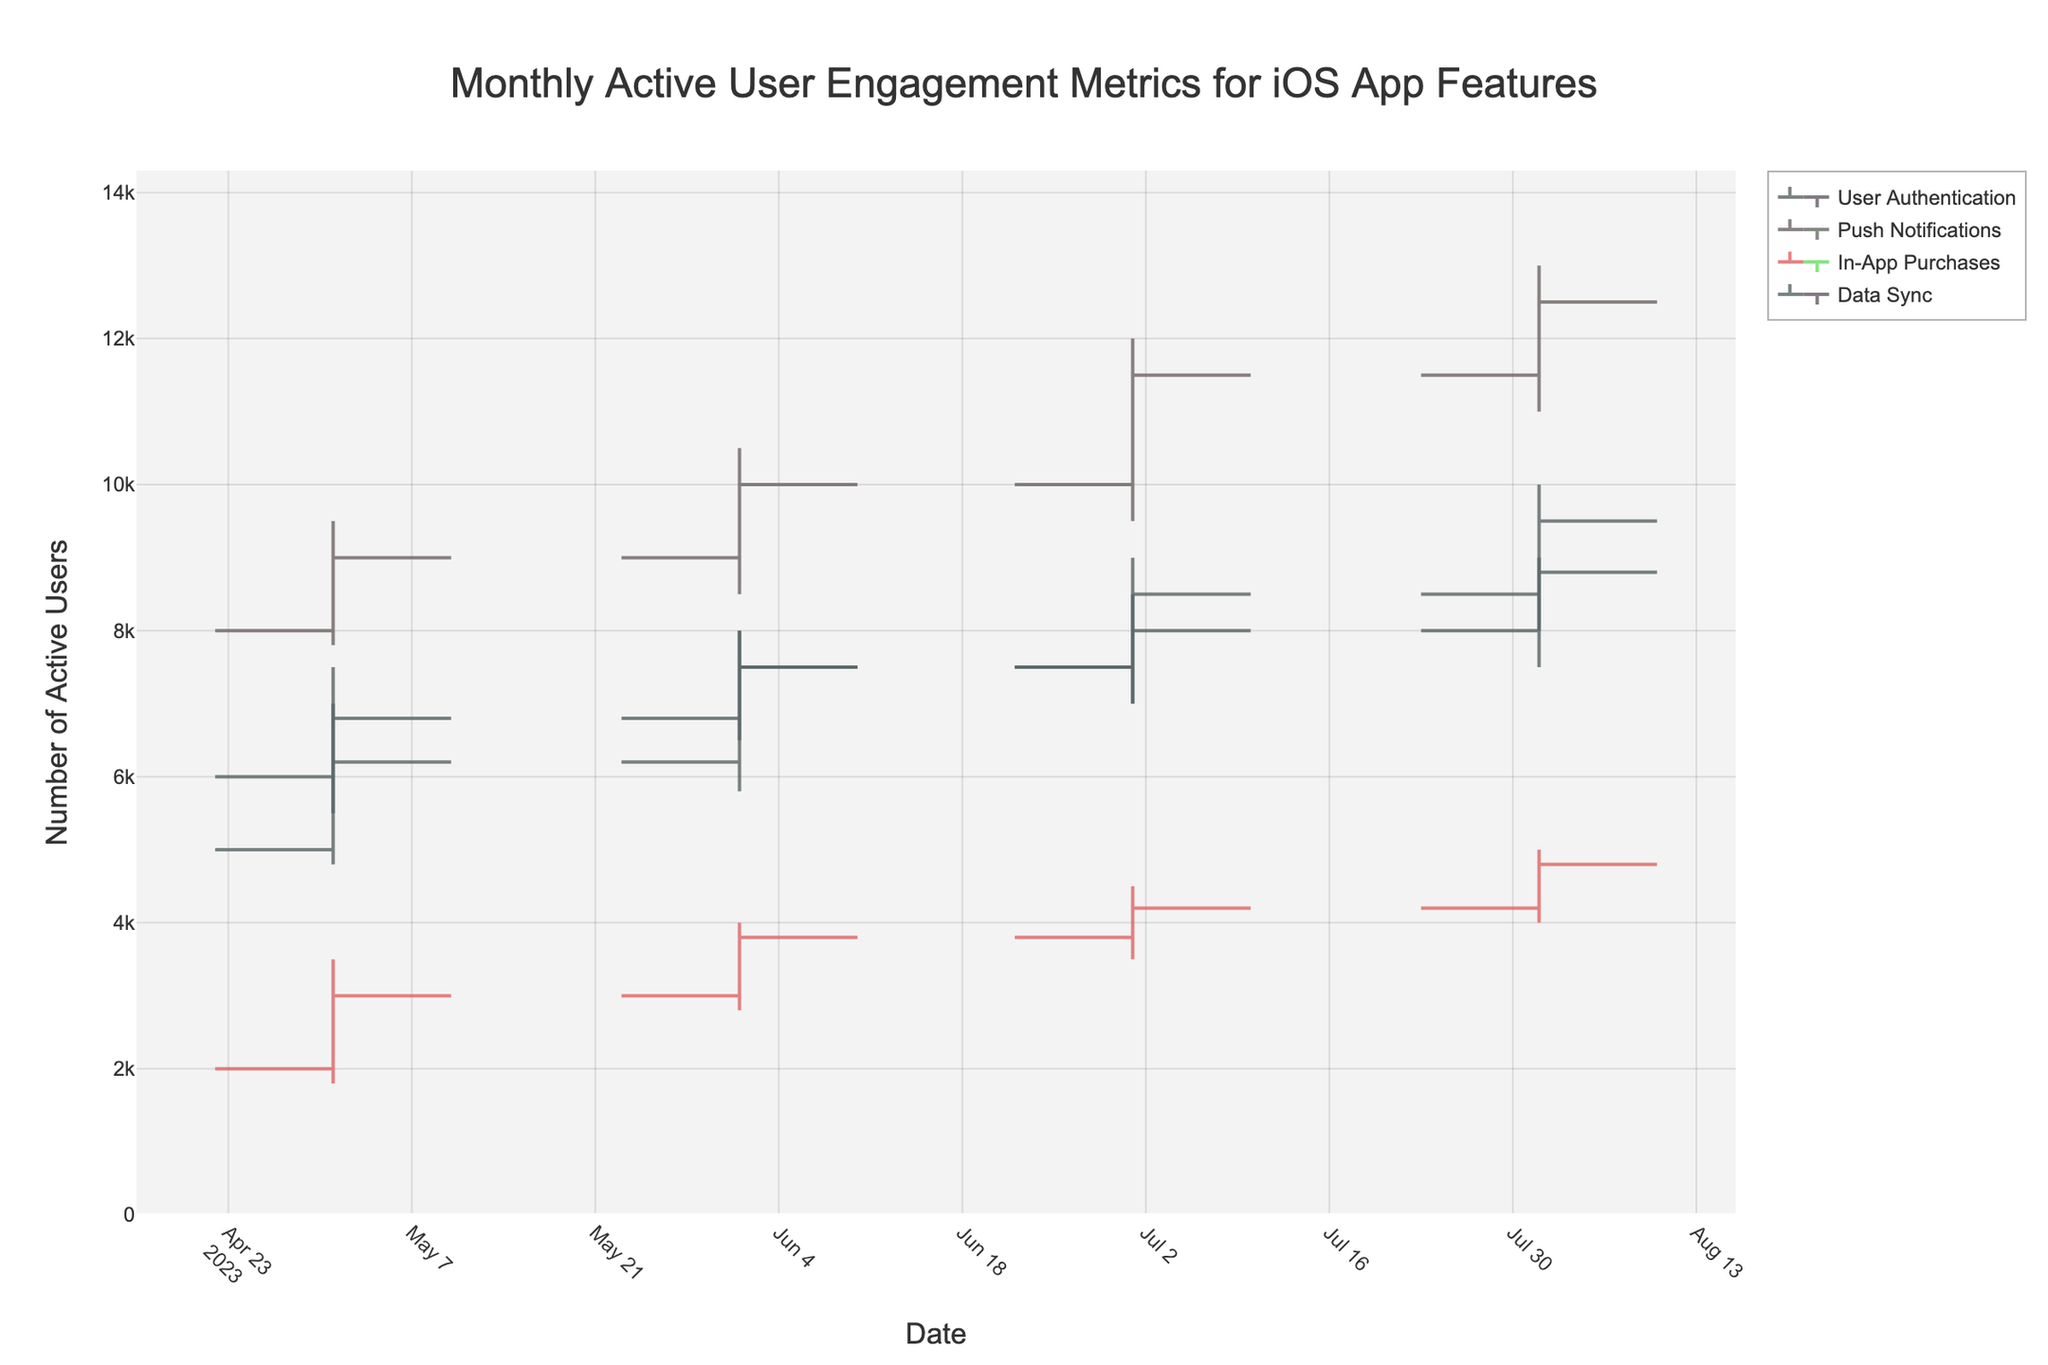What's the title of the chart? The title is displayed at the top of the chart. It reads "Monthly Active User Engagement Metrics for iOS App Features."
Answer: Monthly Active User Engagement Metrics for iOS App Features Which feature had the highest number of active users in July 2023? In July 2023, the feature with the highest number of active users can be found by looking for the highest "High" value in July. Push Notifications has the highest "High" value of 12000.
Answer: Push Notifications What is the difference in the closing values for "User Authentication" between May and August 2023? To find the difference, subtract the closing value in May (6200) from the closing value in August (9500). This results in a difference of 9500 - 6200 = 3300.
Answer: 3300 How did the engagement for "In-App Purchases" change from June to July 2023? Comparing the closing values for "In-App Purchases" from June (3800) to July (4200), the engagement increased by 4200 - 3800 = 400.
Answer: Increased by 400 Which month had the lowest engagement for the "Data Sync" feature? The lowest engagement for "Data Sync" is found by identifying the lowest "Low" value across all months. In May 2023, the "Low" value for "Data Sync" is 5500, which is the lowest.
Answer: May 2023 On what month did "Push Notifications" experience the greatest increase in active users (based on closing values)? To determine the greatest increase, we compare the closing values month-over-month. The increase from June (10000) to July (11500) is 1500, which is the greatest increase.
Answer: July 2023 What is the average high value for the "User Authentication" feature over the given months? The high values for "User Authentication" are: 7500, 8000, 9000, 10000. The average is calculated as (7500 + 8000 + 9000 + 10000) / 4 = 34500 / 4 = 8625.
Answer: 8625 Did any feature have a decreasing trend in its closing values from June to August 2023? To identify a decreasing trend, check the closing values for each feature from June to August. "In-App Purchases" does not show a decreasing trend since its closing values from June (3800) to August (4800) show an increase. No other feature shows a decreasing trend in that period.
Answer: No By how much did the "Data Sync" feature's engagement (based on the closing values) increase from May to August 2023? To find the increase, subtract the closing value in May (6800) from the closing value in August (8800). This results in 8800 - 6800 = 2000.
Answer: 2000 